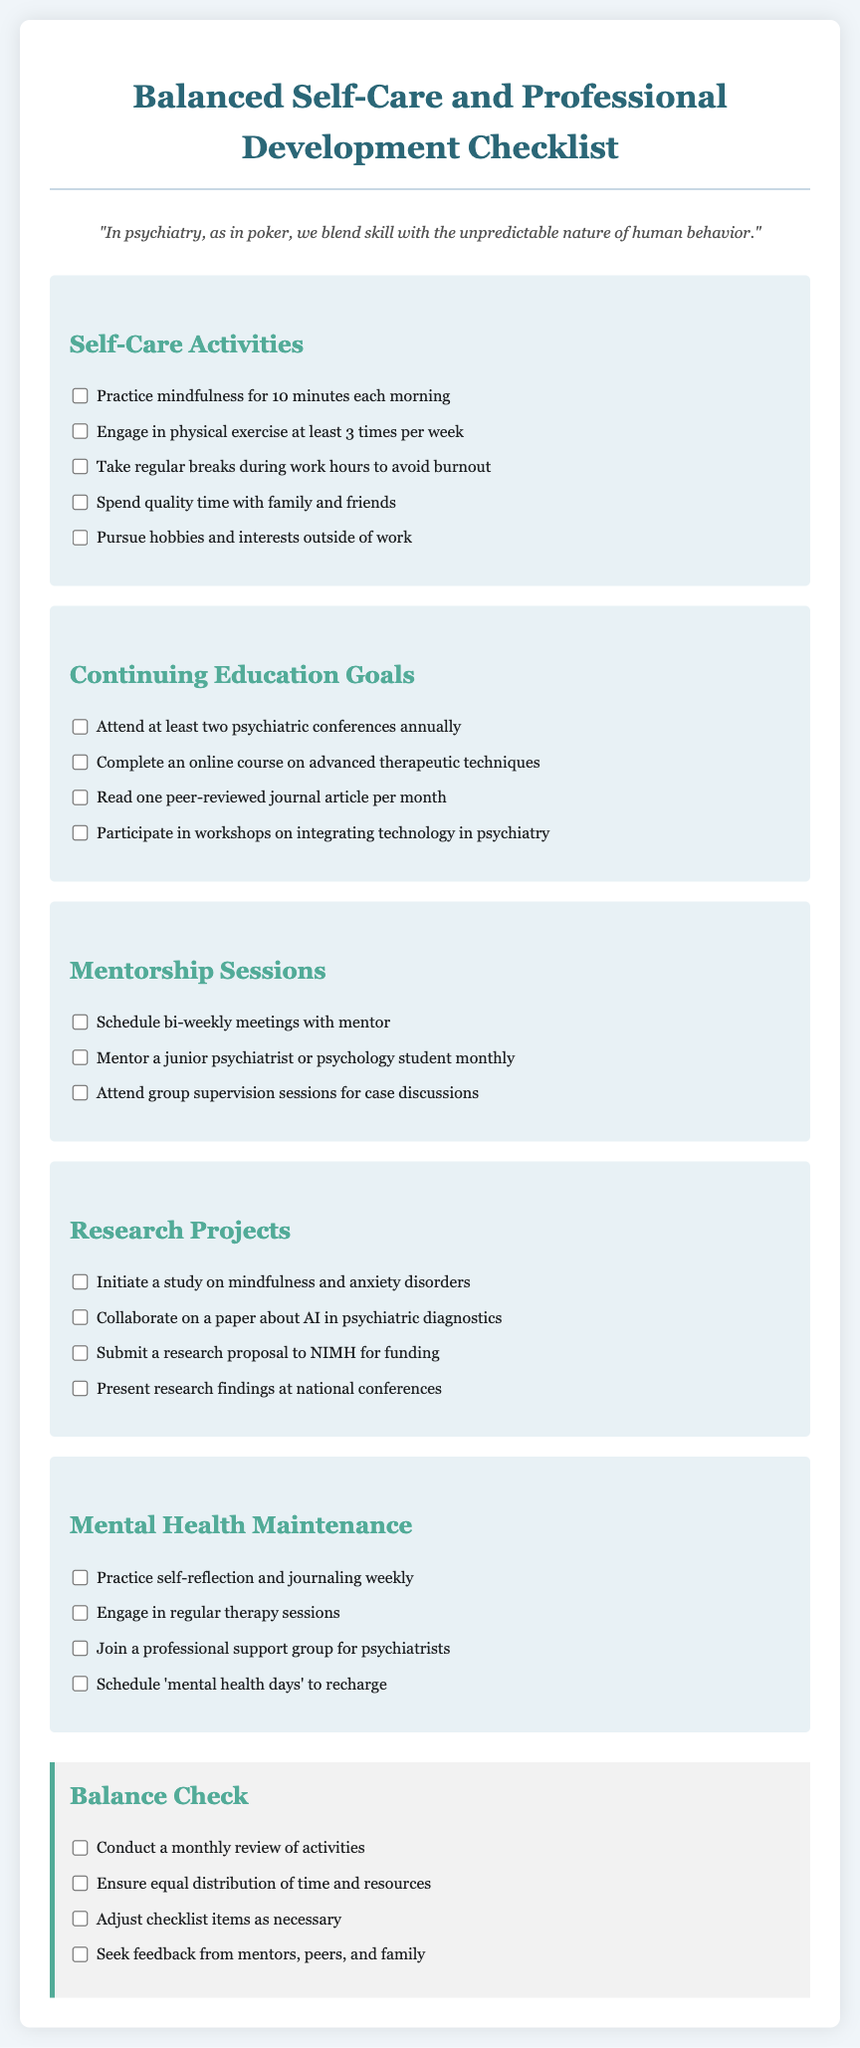What is the title of the checklist? The title of the checklist is prominently displayed at the top of the document.
Answer: Balanced Self-Care and Professional Development Checklist How many self-care activities are listed? By counting the self-care activities provided in the checklist, we find the total number.
Answer: Five What is one of the continuing education goals? Continuing education goals are specified in the provided section, and one can be identified.
Answer: Attend at least two psychiatric conferences annually How often should mentorship sessions be scheduled? The mentorship sessions section specifies the frequency of meetings.
Answer: Bi-weekly What type of study is suggested for research projects? The research projects section contains specific topics, one of which can be identified.
Answer: Mindfulness and anxiety disorders What should be included in the balance check? The balance check section outlines specific actions to ensure well-being and growth.
Answer: Monthly review of activities What is the purpose of engaging in regular therapy sessions? The mental health maintenance section specifies the importance of certain activities for well-being.
Answer: Mental health maintenance How many total categories are there in the checklist? By examining the document structure, we can determine the number of categories included.
Answer: Five 